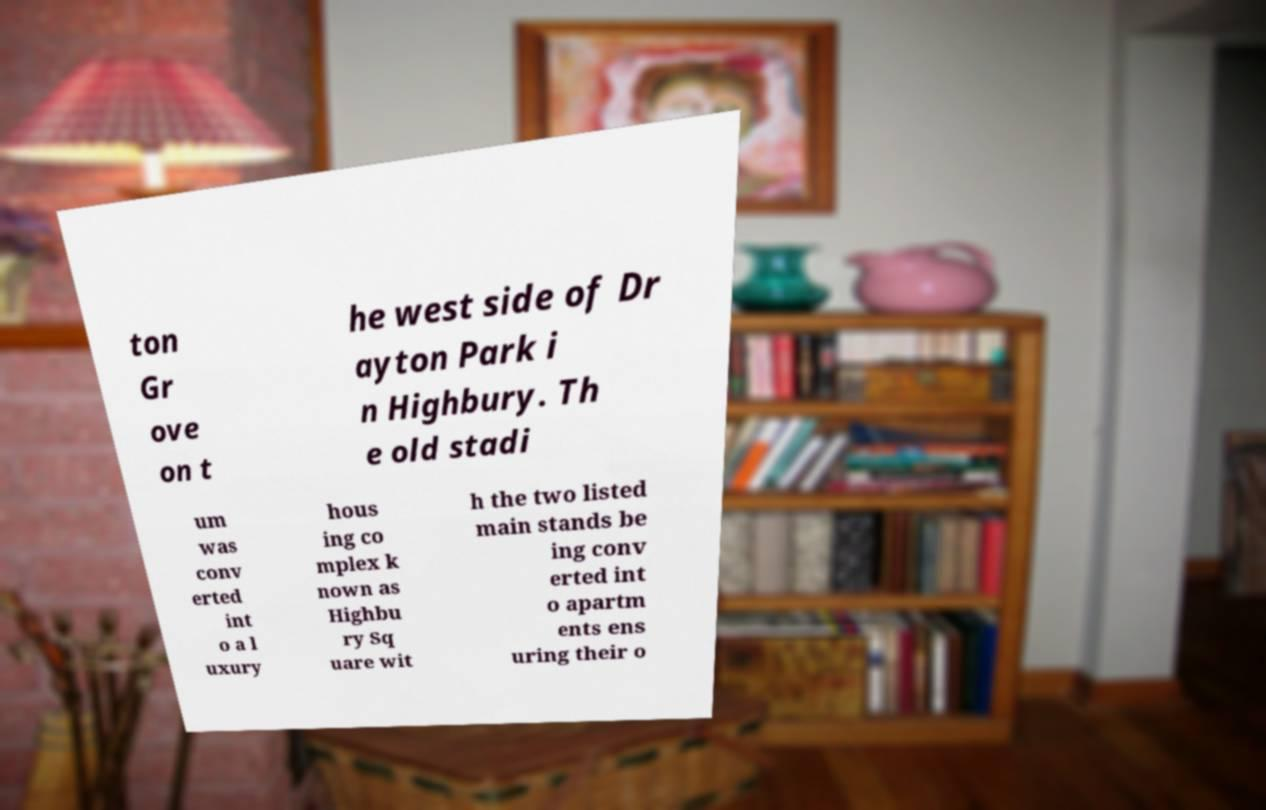There's text embedded in this image that I need extracted. Can you transcribe it verbatim? ton Gr ove on t he west side of Dr ayton Park i n Highbury. Th e old stadi um was conv erted int o a l uxury hous ing co mplex k nown as Highbu ry Sq uare wit h the two listed main stands be ing conv erted int o apartm ents ens uring their o 